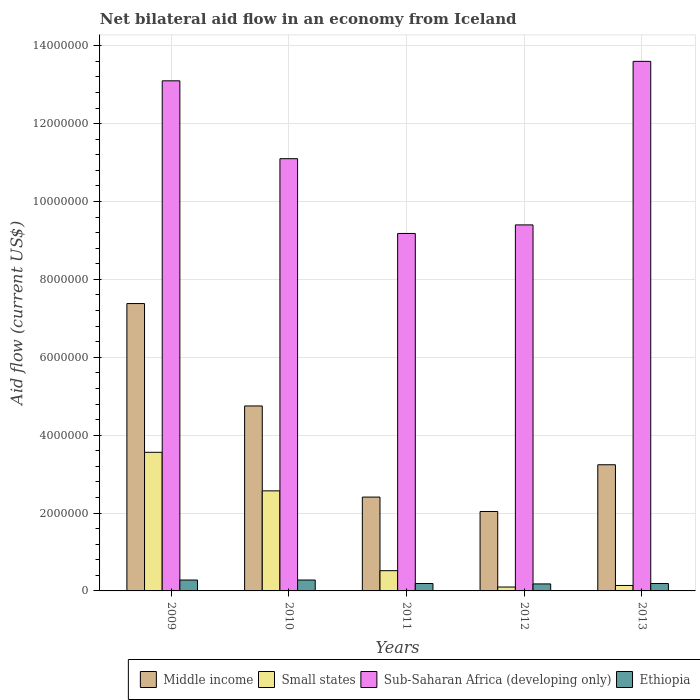How many different coloured bars are there?
Offer a very short reply. 4. How many groups of bars are there?
Your response must be concise. 5. Are the number of bars per tick equal to the number of legend labels?
Keep it short and to the point. Yes. Are the number of bars on each tick of the X-axis equal?
Keep it short and to the point. Yes. How many bars are there on the 3rd tick from the right?
Your answer should be compact. 4. What is the label of the 2nd group of bars from the left?
Give a very brief answer. 2010. In how many cases, is the number of bars for a given year not equal to the number of legend labels?
Provide a short and direct response. 0. What is the net bilateral aid flow in Small states in 2010?
Ensure brevity in your answer.  2.57e+06. Across all years, what is the minimum net bilateral aid flow in Middle income?
Offer a terse response. 2.04e+06. In which year was the net bilateral aid flow in Small states minimum?
Offer a very short reply. 2012. What is the total net bilateral aid flow in Sub-Saharan Africa (developing only) in the graph?
Your answer should be compact. 5.64e+07. What is the difference between the net bilateral aid flow in Middle income in 2011 and that in 2013?
Your answer should be very brief. -8.30e+05. What is the difference between the net bilateral aid flow in Small states in 2010 and the net bilateral aid flow in Ethiopia in 2013?
Ensure brevity in your answer.  2.38e+06. What is the average net bilateral aid flow in Ethiopia per year?
Your answer should be compact. 2.24e+05. In the year 2009, what is the difference between the net bilateral aid flow in Ethiopia and net bilateral aid flow in Middle income?
Your response must be concise. -7.10e+06. In how many years, is the net bilateral aid flow in Sub-Saharan Africa (developing only) greater than 1200000 US$?
Give a very brief answer. 5. What is the ratio of the net bilateral aid flow in Middle income in 2010 to that in 2013?
Your answer should be compact. 1.47. Is the difference between the net bilateral aid flow in Ethiopia in 2012 and 2013 greater than the difference between the net bilateral aid flow in Middle income in 2012 and 2013?
Your response must be concise. Yes. What is the difference between the highest and the second highest net bilateral aid flow in Sub-Saharan Africa (developing only)?
Keep it short and to the point. 5.00e+05. What is the difference between the highest and the lowest net bilateral aid flow in Middle income?
Ensure brevity in your answer.  5.34e+06. In how many years, is the net bilateral aid flow in Small states greater than the average net bilateral aid flow in Small states taken over all years?
Ensure brevity in your answer.  2. What does the 2nd bar from the left in 2011 represents?
Make the answer very short. Small states. What does the 1st bar from the right in 2009 represents?
Give a very brief answer. Ethiopia. Is it the case that in every year, the sum of the net bilateral aid flow in Middle income and net bilateral aid flow in Sub-Saharan Africa (developing only) is greater than the net bilateral aid flow in Small states?
Ensure brevity in your answer.  Yes. Does the graph contain any zero values?
Provide a short and direct response. No. Does the graph contain grids?
Make the answer very short. Yes. How are the legend labels stacked?
Offer a very short reply. Horizontal. What is the title of the graph?
Keep it short and to the point. Net bilateral aid flow in an economy from Iceland. Does "Timor-Leste" appear as one of the legend labels in the graph?
Your answer should be compact. No. What is the label or title of the Y-axis?
Your answer should be very brief. Aid flow (current US$). What is the Aid flow (current US$) in Middle income in 2009?
Your answer should be compact. 7.38e+06. What is the Aid flow (current US$) in Small states in 2009?
Provide a succinct answer. 3.56e+06. What is the Aid flow (current US$) of Sub-Saharan Africa (developing only) in 2009?
Offer a terse response. 1.31e+07. What is the Aid flow (current US$) in Ethiopia in 2009?
Provide a short and direct response. 2.80e+05. What is the Aid flow (current US$) of Middle income in 2010?
Make the answer very short. 4.75e+06. What is the Aid flow (current US$) in Small states in 2010?
Offer a very short reply. 2.57e+06. What is the Aid flow (current US$) in Sub-Saharan Africa (developing only) in 2010?
Your answer should be very brief. 1.11e+07. What is the Aid flow (current US$) of Middle income in 2011?
Your answer should be very brief. 2.41e+06. What is the Aid flow (current US$) of Small states in 2011?
Your answer should be compact. 5.20e+05. What is the Aid flow (current US$) in Sub-Saharan Africa (developing only) in 2011?
Give a very brief answer. 9.18e+06. What is the Aid flow (current US$) in Middle income in 2012?
Give a very brief answer. 2.04e+06. What is the Aid flow (current US$) in Small states in 2012?
Give a very brief answer. 1.00e+05. What is the Aid flow (current US$) in Sub-Saharan Africa (developing only) in 2012?
Provide a succinct answer. 9.40e+06. What is the Aid flow (current US$) in Ethiopia in 2012?
Your answer should be compact. 1.80e+05. What is the Aid flow (current US$) in Middle income in 2013?
Your answer should be compact. 3.24e+06. What is the Aid flow (current US$) of Small states in 2013?
Your answer should be very brief. 1.40e+05. What is the Aid flow (current US$) of Sub-Saharan Africa (developing only) in 2013?
Provide a succinct answer. 1.36e+07. Across all years, what is the maximum Aid flow (current US$) in Middle income?
Offer a very short reply. 7.38e+06. Across all years, what is the maximum Aid flow (current US$) of Small states?
Give a very brief answer. 3.56e+06. Across all years, what is the maximum Aid flow (current US$) of Sub-Saharan Africa (developing only)?
Keep it short and to the point. 1.36e+07. Across all years, what is the minimum Aid flow (current US$) of Middle income?
Make the answer very short. 2.04e+06. Across all years, what is the minimum Aid flow (current US$) of Small states?
Offer a terse response. 1.00e+05. Across all years, what is the minimum Aid flow (current US$) in Sub-Saharan Africa (developing only)?
Keep it short and to the point. 9.18e+06. What is the total Aid flow (current US$) in Middle income in the graph?
Ensure brevity in your answer.  1.98e+07. What is the total Aid flow (current US$) of Small states in the graph?
Provide a short and direct response. 6.89e+06. What is the total Aid flow (current US$) of Sub-Saharan Africa (developing only) in the graph?
Ensure brevity in your answer.  5.64e+07. What is the total Aid flow (current US$) of Ethiopia in the graph?
Make the answer very short. 1.12e+06. What is the difference between the Aid flow (current US$) in Middle income in 2009 and that in 2010?
Give a very brief answer. 2.63e+06. What is the difference between the Aid flow (current US$) of Small states in 2009 and that in 2010?
Provide a succinct answer. 9.90e+05. What is the difference between the Aid flow (current US$) in Sub-Saharan Africa (developing only) in 2009 and that in 2010?
Ensure brevity in your answer.  2.00e+06. What is the difference between the Aid flow (current US$) in Middle income in 2009 and that in 2011?
Your answer should be compact. 4.97e+06. What is the difference between the Aid flow (current US$) in Small states in 2009 and that in 2011?
Provide a succinct answer. 3.04e+06. What is the difference between the Aid flow (current US$) of Sub-Saharan Africa (developing only) in 2009 and that in 2011?
Offer a terse response. 3.92e+06. What is the difference between the Aid flow (current US$) in Ethiopia in 2009 and that in 2011?
Keep it short and to the point. 9.00e+04. What is the difference between the Aid flow (current US$) of Middle income in 2009 and that in 2012?
Offer a very short reply. 5.34e+06. What is the difference between the Aid flow (current US$) of Small states in 2009 and that in 2012?
Your response must be concise. 3.46e+06. What is the difference between the Aid flow (current US$) in Sub-Saharan Africa (developing only) in 2009 and that in 2012?
Keep it short and to the point. 3.70e+06. What is the difference between the Aid flow (current US$) of Middle income in 2009 and that in 2013?
Provide a succinct answer. 4.14e+06. What is the difference between the Aid flow (current US$) of Small states in 2009 and that in 2013?
Ensure brevity in your answer.  3.42e+06. What is the difference between the Aid flow (current US$) of Sub-Saharan Africa (developing only) in 2009 and that in 2013?
Your response must be concise. -5.00e+05. What is the difference between the Aid flow (current US$) in Ethiopia in 2009 and that in 2013?
Provide a short and direct response. 9.00e+04. What is the difference between the Aid flow (current US$) in Middle income in 2010 and that in 2011?
Make the answer very short. 2.34e+06. What is the difference between the Aid flow (current US$) in Small states in 2010 and that in 2011?
Make the answer very short. 2.05e+06. What is the difference between the Aid flow (current US$) of Sub-Saharan Africa (developing only) in 2010 and that in 2011?
Ensure brevity in your answer.  1.92e+06. What is the difference between the Aid flow (current US$) in Middle income in 2010 and that in 2012?
Keep it short and to the point. 2.71e+06. What is the difference between the Aid flow (current US$) of Small states in 2010 and that in 2012?
Provide a short and direct response. 2.47e+06. What is the difference between the Aid flow (current US$) of Sub-Saharan Africa (developing only) in 2010 and that in 2012?
Your answer should be compact. 1.70e+06. What is the difference between the Aid flow (current US$) of Ethiopia in 2010 and that in 2012?
Provide a succinct answer. 1.00e+05. What is the difference between the Aid flow (current US$) in Middle income in 2010 and that in 2013?
Offer a very short reply. 1.51e+06. What is the difference between the Aid flow (current US$) of Small states in 2010 and that in 2013?
Your answer should be very brief. 2.43e+06. What is the difference between the Aid flow (current US$) of Sub-Saharan Africa (developing only) in 2010 and that in 2013?
Provide a short and direct response. -2.50e+06. What is the difference between the Aid flow (current US$) in Sub-Saharan Africa (developing only) in 2011 and that in 2012?
Provide a short and direct response. -2.20e+05. What is the difference between the Aid flow (current US$) in Ethiopia in 2011 and that in 2012?
Your response must be concise. 10000. What is the difference between the Aid flow (current US$) of Middle income in 2011 and that in 2013?
Offer a terse response. -8.30e+05. What is the difference between the Aid flow (current US$) in Small states in 2011 and that in 2013?
Your answer should be very brief. 3.80e+05. What is the difference between the Aid flow (current US$) of Sub-Saharan Africa (developing only) in 2011 and that in 2013?
Your answer should be compact. -4.42e+06. What is the difference between the Aid flow (current US$) in Middle income in 2012 and that in 2013?
Give a very brief answer. -1.20e+06. What is the difference between the Aid flow (current US$) in Sub-Saharan Africa (developing only) in 2012 and that in 2013?
Your answer should be compact. -4.20e+06. What is the difference between the Aid flow (current US$) in Middle income in 2009 and the Aid flow (current US$) in Small states in 2010?
Your answer should be compact. 4.81e+06. What is the difference between the Aid flow (current US$) of Middle income in 2009 and the Aid flow (current US$) of Sub-Saharan Africa (developing only) in 2010?
Your answer should be compact. -3.72e+06. What is the difference between the Aid flow (current US$) in Middle income in 2009 and the Aid flow (current US$) in Ethiopia in 2010?
Your answer should be very brief. 7.10e+06. What is the difference between the Aid flow (current US$) in Small states in 2009 and the Aid flow (current US$) in Sub-Saharan Africa (developing only) in 2010?
Give a very brief answer. -7.54e+06. What is the difference between the Aid flow (current US$) in Small states in 2009 and the Aid flow (current US$) in Ethiopia in 2010?
Your answer should be compact. 3.28e+06. What is the difference between the Aid flow (current US$) in Sub-Saharan Africa (developing only) in 2009 and the Aid flow (current US$) in Ethiopia in 2010?
Provide a succinct answer. 1.28e+07. What is the difference between the Aid flow (current US$) in Middle income in 2009 and the Aid flow (current US$) in Small states in 2011?
Your answer should be compact. 6.86e+06. What is the difference between the Aid flow (current US$) in Middle income in 2009 and the Aid flow (current US$) in Sub-Saharan Africa (developing only) in 2011?
Provide a succinct answer. -1.80e+06. What is the difference between the Aid flow (current US$) in Middle income in 2009 and the Aid flow (current US$) in Ethiopia in 2011?
Provide a succinct answer. 7.19e+06. What is the difference between the Aid flow (current US$) of Small states in 2009 and the Aid flow (current US$) of Sub-Saharan Africa (developing only) in 2011?
Make the answer very short. -5.62e+06. What is the difference between the Aid flow (current US$) of Small states in 2009 and the Aid flow (current US$) of Ethiopia in 2011?
Make the answer very short. 3.37e+06. What is the difference between the Aid flow (current US$) of Sub-Saharan Africa (developing only) in 2009 and the Aid flow (current US$) of Ethiopia in 2011?
Make the answer very short. 1.29e+07. What is the difference between the Aid flow (current US$) of Middle income in 2009 and the Aid flow (current US$) of Small states in 2012?
Your answer should be very brief. 7.28e+06. What is the difference between the Aid flow (current US$) of Middle income in 2009 and the Aid flow (current US$) of Sub-Saharan Africa (developing only) in 2012?
Your response must be concise. -2.02e+06. What is the difference between the Aid flow (current US$) of Middle income in 2009 and the Aid flow (current US$) of Ethiopia in 2012?
Keep it short and to the point. 7.20e+06. What is the difference between the Aid flow (current US$) in Small states in 2009 and the Aid flow (current US$) in Sub-Saharan Africa (developing only) in 2012?
Offer a very short reply. -5.84e+06. What is the difference between the Aid flow (current US$) in Small states in 2009 and the Aid flow (current US$) in Ethiopia in 2012?
Provide a succinct answer. 3.38e+06. What is the difference between the Aid flow (current US$) in Sub-Saharan Africa (developing only) in 2009 and the Aid flow (current US$) in Ethiopia in 2012?
Provide a short and direct response. 1.29e+07. What is the difference between the Aid flow (current US$) of Middle income in 2009 and the Aid flow (current US$) of Small states in 2013?
Provide a short and direct response. 7.24e+06. What is the difference between the Aid flow (current US$) in Middle income in 2009 and the Aid flow (current US$) in Sub-Saharan Africa (developing only) in 2013?
Give a very brief answer. -6.22e+06. What is the difference between the Aid flow (current US$) in Middle income in 2009 and the Aid flow (current US$) in Ethiopia in 2013?
Your answer should be very brief. 7.19e+06. What is the difference between the Aid flow (current US$) of Small states in 2009 and the Aid flow (current US$) of Sub-Saharan Africa (developing only) in 2013?
Your response must be concise. -1.00e+07. What is the difference between the Aid flow (current US$) in Small states in 2009 and the Aid flow (current US$) in Ethiopia in 2013?
Ensure brevity in your answer.  3.37e+06. What is the difference between the Aid flow (current US$) in Sub-Saharan Africa (developing only) in 2009 and the Aid flow (current US$) in Ethiopia in 2013?
Give a very brief answer. 1.29e+07. What is the difference between the Aid flow (current US$) of Middle income in 2010 and the Aid flow (current US$) of Small states in 2011?
Ensure brevity in your answer.  4.23e+06. What is the difference between the Aid flow (current US$) in Middle income in 2010 and the Aid flow (current US$) in Sub-Saharan Africa (developing only) in 2011?
Your answer should be compact. -4.43e+06. What is the difference between the Aid flow (current US$) in Middle income in 2010 and the Aid flow (current US$) in Ethiopia in 2011?
Your answer should be very brief. 4.56e+06. What is the difference between the Aid flow (current US$) in Small states in 2010 and the Aid flow (current US$) in Sub-Saharan Africa (developing only) in 2011?
Keep it short and to the point. -6.61e+06. What is the difference between the Aid flow (current US$) in Small states in 2010 and the Aid flow (current US$) in Ethiopia in 2011?
Give a very brief answer. 2.38e+06. What is the difference between the Aid flow (current US$) in Sub-Saharan Africa (developing only) in 2010 and the Aid flow (current US$) in Ethiopia in 2011?
Make the answer very short. 1.09e+07. What is the difference between the Aid flow (current US$) in Middle income in 2010 and the Aid flow (current US$) in Small states in 2012?
Your response must be concise. 4.65e+06. What is the difference between the Aid flow (current US$) in Middle income in 2010 and the Aid flow (current US$) in Sub-Saharan Africa (developing only) in 2012?
Offer a terse response. -4.65e+06. What is the difference between the Aid flow (current US$) of Middle income in 2010 and the Aid flow (current US$) of Ethiopia in 2012?
Your response must be concise. 4.57e+06. What is the difference between the Aid flow (current US$) in Small states in 2010 and the Aid flow (current US$) in Sub-Saharan Africa (developing only) in 2012?
Your response must be concise. -6.83e+06. What is the difference between the Aid flow (current US$) in Small states in 2010 and the Aid flow (current US$) in Ethiopia in 2012?
Give a very brief answer. 2.39e+06. What is the difference between the Aid flow (current US$) of Sub-Saharan Africa (developing only) in 2010 and the Aid flow (current US$) of Ethiopia in 2012?
Offer a terse response. 1.09e+07. What is the difference between the Aid flow (current US$) in Middle income in 2010 and the Aid flow (current US$) in Small states in 2013?
Provide a short and direct response. 4.61e+06. What is the difference between the Aid flow (current US$) of Middle income in 2010 and the Aid flow (current US$) of Sub-Saharan Africa (developing only) in 2013?
Offer a very short reply. -8.85e+06. What is the difference between the Aid flow (current US$) of Middle income in 2010 and the Aid flow (current US$) of Ethiopia in 2013?
Give a very brief answer. 4.56e+06. What is the difference between the Aid flow (current US$) of Small states in 2010 and the Aid flow (current US$) of Sub-Saharan Africa (developing only) in 2013?
Keep it short and to the point. -1.10e+07. What is the difference between the Aid flow (current US$) in Small states in 2010 and the Aid flow (current US$) in Ethiopia in 2013?
Ensure brevity in your answer.  2.38e+06. What is the difference between the Aid flow (current US$) of Sub-Saharan Africa (developing only) in 2010 and the Aid flow (current US$) of Ethiopia in 2013?
Make the answer very short. 1.09e+07. What is the difference between the Aid flow (current US$) in Middle income in 2011 and the Aid flow (current US$) in Small states in 2012?
Your answer should be compact. 2.31e+06. What is the difference between the Aid flow (current US$) of Middle income in 2011 and the Aid flow (current US$) of Sub-Saharan Africa (developing only) in 2012?
Offer a very short reply. -6.99e+06. What is the difference between the Aid flow (current US$) of Middle income in 2011 and the Aid flow (current US$) of Ethiopia in 2012?
Keep it short and to the point. 2.23e+06. What is the difference between the Aid flow (current US$) in Small states in 2011 and the Aid flow (current US$) in Sub-Saharan Africa (developing only) in 2012?
Keep it short and to the point. -8.88e+06. What is the difference between the Aid flow (current US$) of Sub-Saharan Africa (developing only) in 2011 and the Aid flow (current US$) of Ethiopia in 2012?
Make the answer very short. 9.00e+06. What is the difference between the Aid flow (current US$) of Middle income in 2011 and the Aid flow (current US$) of Small states in 2013?
Ensure brevity in your answer.  2.27e+06. What is the difference between the Aid flow (current US$) in Middle income in 2011 and the Aid flow (current US$) in Sub-Saharan Africa (developing only) in 2013?
Give a very brief answer. -1.12e+07. What is the difference between the Aid flow (current US$) of Middle income in 2011 and the Aid flow (current US$) of Ethiopia in 2013?
Keep it short and to the point. 2.22e+06. What is the difference between the Aid flow (current US$) of Small states in 2011 and the Aid flow (current US$) of Sub-Saharan Africa (developing only) in 2013?
Make the answer very short. -1.31e+07. What is the difference between the Aid flow (current US$) in Sub-Saharan Africa (developing only) in 2011 and the Aid flow (current US$) in Ethiopia in 2013?
Your answer should be compact. 8.99e+06. What is the difference between the Aid flow (current US$) in Middle income in 2012 and the Aid flow (current US$) in Small states in 2013?
Your response must be concise. 1.90e+06. What is the difference between the Aid flow (current US$) of Middle income in 2012 and the Aid flow (current US$) of Sub-Saharan Africa (developing only) in 2013?
Provide a short and direct response. -1.16e+07. What is the difference between the Aid flow (current US$) of Middle income in 2012 and the Aid flow (current US$) of Ethiopia in 2013?
Offer a terse response. 1.85e+06. What is the difference between the Aid flow (current US$) in Small states in 2012 and the Aid flow (current US$) in Sub-Saharan Africa (developing only) in 2013?
Keep it short and to the point. -1.35e+07. What is the difference between the Aid flow (current US$) of Sub-Saharan Africa (developing only) in 2012 and the Aid flow (current US$) of Ethiopia in 2013?
Provide a short and direct response. 9.21e+06. What is the average Aid flow (current US$) of Middle income per year?
Your response must be concise. 3.96e+06. What is the average Aid flow (current US$) in Small states per year?
Ensure brevity in your answer.  1.38e+06. What is the average Aid flow (current US$) in Sub-Saharan Africa (developing only) per year?
Offer a terse response. 1.13e+07. What is the average Aid flow (current US$) of Ethiopia per year?
Ensure brevity in your answer.  2.24e+05. In the year 2009, what is the difference between the Aid flow (current US$) in Middle income and Aid flow (current US$) in Small states?
Offer a very short reply. 3.82e+06. In the year 2009, what is the difference between the Aid flow (current US$) of Middle income and Aid flow (current US$) of Sub-Saharan Africa (developing only)?
Offer a terse response. -5.72e+06. In the year 2009, what is the difference between the Aid flow (current US$) in Middle income and Aid flow (current US$) in Ethiopia?
Make the answer very short. 7.10e+06. In the year 2009, what is the difference between the Aid flow (current US$) in Small states and Aid flow (current US$) in Sub-Saharan Africa (developing only)?
Provide a short and direct response. -9.54e+06. In the year 2009, what is the difference between the Aid flow (current US$) in Small states and Aid flow (current US$) in Ethiopia?
Offer a very short reply. 3.28e+06. In the year 2009, what is the difference between the Aid flow (current US$) of Sub-Saharan Africa (developing only) and Aid flow (current US$) of Ethiopia?
Make the answer very short. 1.28e+07. In the year 2010, what is the difference between the Aid flow (current US$) in Middle income and Aid flow (current US$) in Small states?
Offer a terse response. 2.18e+06. In the year 2010, what is the difference between the Aid flow (current US$) of Middle income and Aid flow (current US$) of Sub-Saharan Africa (developing only)?
Your response must be concise. -6.35e+06. In the year 2010, what is the difference between the Aid flow (current US$) of Middle income and Aid flow (current US$) of Ethiopia?
Provide a short and direct response. 4.47e+06. In the year 2010, what is the difference between the Aid flow (current US$) in Small states and Aid flow (current US$) in Sub-Saharan Africa (developing only)?
Keep it short and to the point. -8.53e+06. In the year 2010, what is the difference between the Aid flow (current US$) of Small states and Aid flow (current US$) of Ethiopia?
Your answer should be very brief. 2.29e+06. In the year 2010, what is the difference between the Aid flow (current US$) in Sub-Saharan Africa (developing only) and Aid flow (current US$) in Ethiopia?
Your response must be concise. 1.08e+07. In the year 2011, what is the difference between the Aid flow (current US$) in Middle income and Aid flow (current US$) in Small states?
Keep it short and to the point. 1.89e+06. In the year 2011, what is the difference between the Aid flow (current US$) in Middle income and Aid flow (current US$) in Sub-Saharan Africa (developing only)?
Keep it short and to the point. -6.77e+06. In the year 2011, what is the difference between the Aid flow (current US$) of Middle income and Aid flow (current US$) of Ethiopia?
Your response must be concise. 2.22e+06. In the year 2011, what is the difference between the Aid flow (current US$) of Small states and Aid flow (current US$) of Sub-Saharan Africa (developing only)?
Provide a short and direct response. -8.66e+06. In the year 2011, what is the difference between the Aid flow (current US$) in Sub-Saharan Africa (developing only) and Aid flow (current US$) in Ethiopia?
Your answer should be compact. 8.99e+06. In the year 2012, what is the difference between the Aid flow (current US$) in Middle income and Aid flow (current US$) in Small states?
Ensure brevity in your answer.  1.94e+06. In the year 2012, what is the difference between the Aid flow (current US$) in Middle income and Aid flow (current US$) in Sub-Saharan Africa (developing only)?
Your answer should be very brief. -7.36e+06. In the year 2012, what is the difference between the Aid flow (current US$) of Middle income and Aid flow (current US$) of Ethiopia?
Give a very brief answer. 1.86e+06. In the year 2012, what is the difference between the Aid flow (current US$) in Small states and Aid flow (current US$) in Sub-Saharan Africa (developing only)?
Provide a succinct answer. -9.30e+06. In the year 2012, what is the difference between the Aid flow (current US$) in Sub-Saharan Africa (developing only) and Aid flow (current US$) in Ethiopia?
Provide a short and direct response. 9.22e+06. In the year 2013, what is the difference between the Aid flow (current US$) of Middle income and Aid flow (current US$) of Small states?
Keep it short and to the point. 3.10e+06. In the year 2013, what is the difference between the Aid flow (current US$) in Middle income and Aid flow (current US$) in Sub-Saharan Africa (developing only)?
Your answer should be very brief. -1.04e+07. In the year 2013, what is the difference between the Aid flow (current US$) of Middle income and Aid flow (current US$) of Ethiopia?
Give a very brief answer. 3.05e+06. In the year 2013, what is the difference between the Aid flow (current US$) of Small states and Aid flow (current US$) of Sub-Saharan Africa (developing only)?
Ensure brevity in your answer.  -1.35e+07. In the year 2013, what is the difference between the Aid flow (current US$) of Sub-Saharan Africa (developing only) and Aid flow (current US$) of Ethiopia?
Keep it short and to the point. 1.34e+07. What is the ratio of the Aid flow (current US$) of Middle income in 2009 to that in 2010?
Provide a succinct answer. 1.55. What is the ratio of the Aid flow (current US$) in Small states in 2009 to that in 2010?
Make the answer very short. 1.39. What is the ratio of the Aid flow (current US$) in Sub-Saharan Africa (developing only) in 2009 to that in 2010?
Your answer should be compact. 1.18. What is the ratio of the Aid flow (current US$) in Ethiopia in 2009 to that in 2010?
Make the answer very short. 1. What is the ratio of the Aid flow (current US$) in Middle income in 2009 to that in 2011?
Offer a terse response. 3.06. What is the ratio of the Aid flow (current US$) of Small states in 2009 to that in 2011?
Your answer should be very brief. 6.85. What is the ratio of the Aid flow (current US$) of Sub-Saharan Africa (developing only) in 2009 to that in 2011?
Your answer should be very brief. 1.43. What is the ratio of the Aid flow (current US$) of Ethiopia in 2009 to that in 2011?
Provide a short and direct response. 1.47. What is the ratio of the Aid flow (current US$) in Middle income in 2009 to that in 2012?
Provide a short and direct response. 3.62. What is the ratio of the Aid flow (current US$) of Small states in 2009 to that in 2012?
Your response must be concise. 35.6. What is the ratio of the Aid flow (current US$) in Sub-Saharan Africa (developing only) in 2009 to that in 2012?
Provide a short and direct response. 1.39. What is the ratio of the Aid flow (current US$) in Ethiopia in 2009 to that in 2012?
Offer a terse response. 1.56. What is the ratio of the Aid flow (current US$) of Middle income in 2009 to that in 2013?
Make the answer very short. 2.28. What is the ratio of the Aid flow (current US$) in Small states in 2009 to that in 2013?
Your response must be concise. 25.43. What is the ratio of the Aid flow (current US$) in Sub-Saharan Africa (developing only) in 2009 to that in 2013?
Provide a short and direct response. 0.96. What is the ratio of the Aid flow (current US$) of Ethiopia in 2009 to that in 2013?
Ensure brevity in your answer.  1.47. What is the ratio of the Aid flow (current US$) of Middle income in 2010 to that in 2011?
Keep it short and to the point. 1.97. What is the ratio of the Aid flow (current US$) in Small states in 2010 to that in 2011?
Offer a very short reply. 4.94. What is the ratio of the Aid flow (current US$) of Sub-Saharan Africa (developing only) in 2010 to that in 2011?
Ensure brevity in your answer.  1.21. What is the ratio of the Aid flow (current US$) of Ethiopia in 2010 to that in 2011?
Your answer should be very brief. 1.47. What is the ratio of the Aid flow (current US$) in Middle income in 2010 to that in 2012?
Keep it short and to the point. 2.33. What is the ratio of the Aid flow (current US$) in Small states in 2010 to that in 2012?
Provide a short and direct response. 25.7. What is the ratio of the Aid flow (current US$) of Sub-Saharan Africa (developing only) in 2010 to that in 2012?
Ensure brevity in your answer.  1.18. What is the ratio of the Aid flow (current US$) of Ethiopia in 2010 to that in 2012?
Make the answer very short. 1.56. What is the ratio of the Aid flow (current US$) of Middle income in 2010 to that in 2013?
Offer a very short reply. 1.47. What is the ratio of the Aid flow (current US$) in Small states in 2010 to that in 2013?
Keep it short and to the point. 18.36. What is the ratio of the Aid flow (current US$) in Sub-Saharan Africa (developing only) in 2010 to that in 2013?
Provide a succinct answer. 0.82. What is the ratio of the Aid flow (current US$) of Ethiopia in 2010 to that in 2013?
Keep it short and to the point. 1.47. What is the ratio of the Aid flow (current US$) of Middle income in 2011 to that in 2012?
Offer a terse response. 1.18. What is the ratio of the Aid flow (current US$) of Small states in 2011 to that in 2012?
Make the answer very short. 5.2. What is the ratio of the Aid flow (current US$) in Sub-Saharan Africa (developing only) in 2011 to that in 2012?
Provide a succinct answer. 0.98. What is the ratio of the Aid flow (current US$) of Ethiopia in 2011 to that in 2012?
Keep it short and to the point. 1.06. What is the ratio of the Aid flow (current US$) in Middle income in 2011 to that in 2013?
Your answer should be compact. 0.74. What is the ratio of the Aid flow (current US$) in Small states in 2011 to that in 2013?
Give a very brief answer. 3.71. What is the ratio of the Aid flow (current US$) in Sub-Saharan Africa (developing only) in 2011 to that in 2013?
Ensure brevity in your answer.  0.68. What is the ratio of the Aid flow (current US$) of Middle income in 2012 to that in 2013?
Offer a terse response. 0.63. What is the ratio of the Aid flow (current US$) of Small states in 2012 to that in 2013?
Your answer should be very brief. 0.71. What is the ratio of the Aid flow (current US$) in Sub-Saharan Africa (developing only) in 2012 to that in 2013?
Keep it short and to the point. 0.69. What is the ratio of the Aid flow (current US$) of Ethiopia in 2012 to that in 2013?
Your answer should be compact. 0.95. What is the difference between the highest and the second highest Aid flow (current US$) in Middle income?
Provide a short and direct response. 2.63e+06. What is the difference between the highest and the second highest Aid flow (current US$) of Small states?
Ensure brevity in your answer.  9.90e+05. What is the difference between the highest and the lowest Aid flow (current US$) of Middle income?
Your answer should be compact. 5.34e+06. What is the difference between the highest and the lowest Aid flow (current US$) of Small states?
Give a very brief answer. 3.46e+06. What is the difference between the highest and the lowest Aid flow (current US$) of Sub-Saharan Africa (developing only)?
Ensure brevity in your answer.  4.42e+06. 